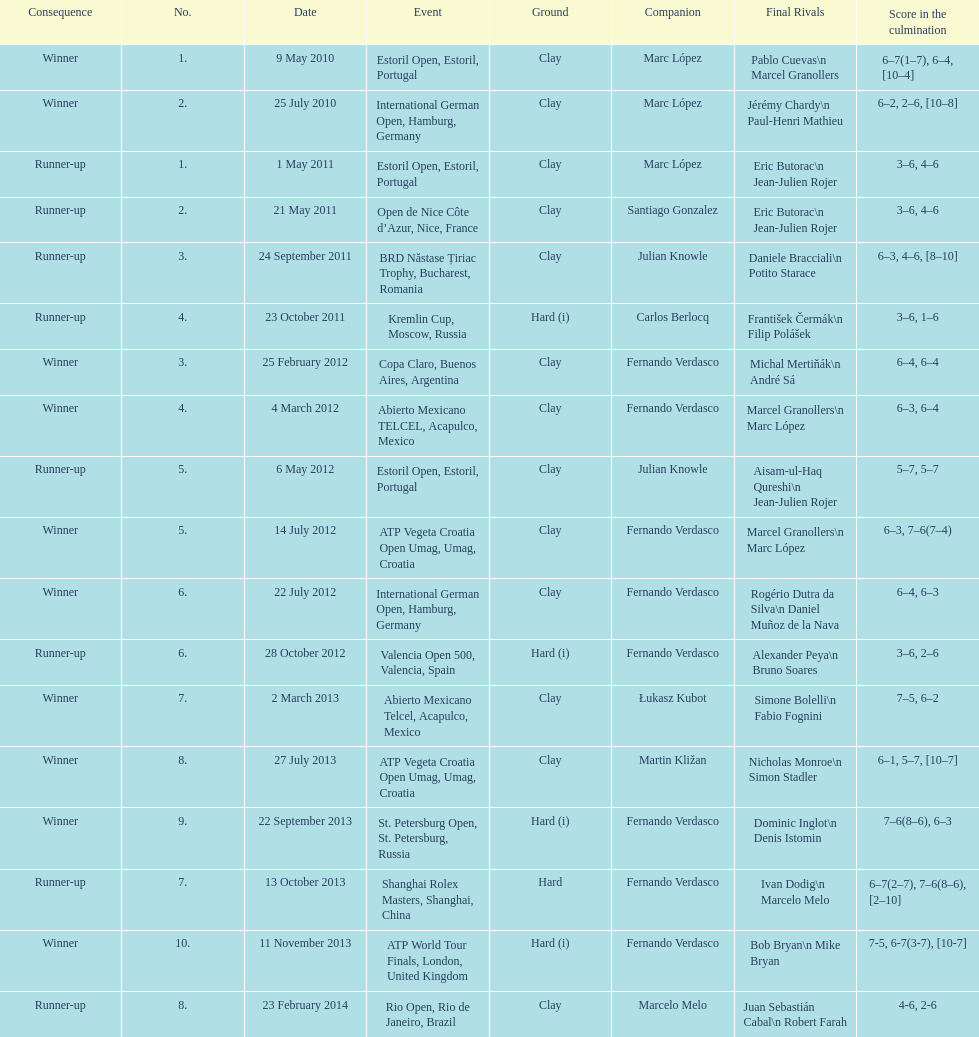Which tournament has the largest number? ATP World Tour Finals. Can you give me this table as a dict? {'header': ['Consequence', 'No.', 'Date', 'Event', 'Ground', 'Companion', 'Final Rivals', 'Score in the culmination'], 'rows': [['Winner', '1.', '9 May 2010', 'Estoril Open, Estoril, Portugal', 'Clay', 'Marc López', 'Pablo Cuevas\\n Marcel Granollers', '6–7(1–7), 6–4, [10–4]'], ['Winner', '2.', '25 July 2010', 'International German Open, Hamburg, Germany', 'Clay', 'Marc López', 'Jérémy Chardy\\n Paul-Henri Mathieu', '6–2, 2–6, [10–8]'], ['Runner-up', '1.', '1 May 2011', 'Estoril Open, Estoril, Portugal', 'Clay', 'Marc López', 'Eric Butorac\\n Jean-Julien Rojer', '3–6, 4–6'], ['Runner-up', '2.', '21 May 2011', 'Open de Nice Côte d’Azur, Nice, France', 'Clay', 'Santiago Gonzalez', 'Eric Butorac\\n Jean-Julien Rojer', '3–6, 4–6'], ['Runner-up', '3.', '24 September 2011', 'BRD Năstase Țiriac Trophy, Bucharest, Romania', 'Clay', 'Julian Knowle', 'Daniele Bracciali\\n Potito Starace', '6–3, 4–6, [8–10]'], ['Runner-up', '4.', '23 October 2011', 'Kremlin Cup, Moscow, Russia', 'Hard (i)', 'Carlos Berlocq', 'František Čermák\\n Filip Polášek', '3–6, 1–6'], ['Winner', '3.', '25 February 2012', 'Copa Claro, Buenos Aires, Argentina', 'Clay', 'Fernando Verdasco', 'Michal Mertiňák\\n André Sá', '6–4, 6–4'], ['Winner', '4.', '4 March 2012', 'Abierto Mexicano TELCEL, Acapulco, Mexico', 'Clay', 'Fernando Verdasco', 'Marcel Granollers\\n Marc López', '6–3, 6–4'], ['Runner-up', '5.', '6 May 2012', 'Estoril Open, Estoril, Portugal', 'Clay', 'Julian Knowle', 'Aisam-ul-Haq Qureshi\\n Jean-Julien Rojer', '5–7, 5–7'], ['Winner', '5.', '14 July 2012', 'ATP Vegeta Croatia Open Umag, Umag, Croatia', 'Clay', 'Fernando Verdasco', 'Marcel Granollers\\n Marc López', '6–3, 7–6(7–4)'], ['Winner', '6.', '22 July 2012', 'International German Open, Hamburg, Germany', 'Clay', 'Fernando Verdasco', 'Rogério Dutra da Silva\\n Daniel Muñoz de la Nava', '6–4, 6–3'], ['Runner-up', '6.', '28 October 2012', 'Valencia Open 500, Valencia, Spain', 'Hard (i)', 'Fernando Verdasco', 'Alexander Peya\\n Bruno Soares', '3–6, 2–6'], ['Winner', '7.', '2 March 2013', 'Abierto Mexicano Telcel, Acapulco, Mexico', 'Clay', 'Łukasz Kubot', 'Simone Bolelli\\n Fabio Fognini', '7–5, 6–2'], ['Winner', '8.', '27 July 2013', 'ATP Vegeta Croatia Open Umag, Umag, Croatia', 'Clay', 'Martin Kližan', 'Nicholas Monroe\\n Simon Stadler', '6–1, 5–7, [10–7]'], ['Winner', '9.', '22 September 2013', 'St. Petersburg Open, St. Petersburg, Russia', 'Hard (i)', 'Fernando Verdasco', 'Dominic Inglot\\n Denis Istomin', '7–6(8–6), 6–3'], ['Runner-up', '7.', '13 October 2013', 'Shanghai Rolex Masters, Shanghai, China', 'Hard', 'Fernando Verdasco', 'Ivan Dodig\\n Marcelo Melo', '6–7(2–7), 7–6(8–6), [2–10]'], ['Winner', '10.', '11 November 2013', 'ATP World Tour Finals, London, United Kingdom', 'Hard (i)', 'Fernando Verdasco', 'Bob Bryan\\n Mike Bryan', '7-5, 6-7(3-7), [10-7]'], ['Runner-up', '8.', '23 February 2014', 'Rio Open, Rio de Janeiro, Brazil', 'Clay', 'Marcelo Melo', 'Juan Sebastián Cabal\\n Robert Farah', '4-6, 2-6']]} 